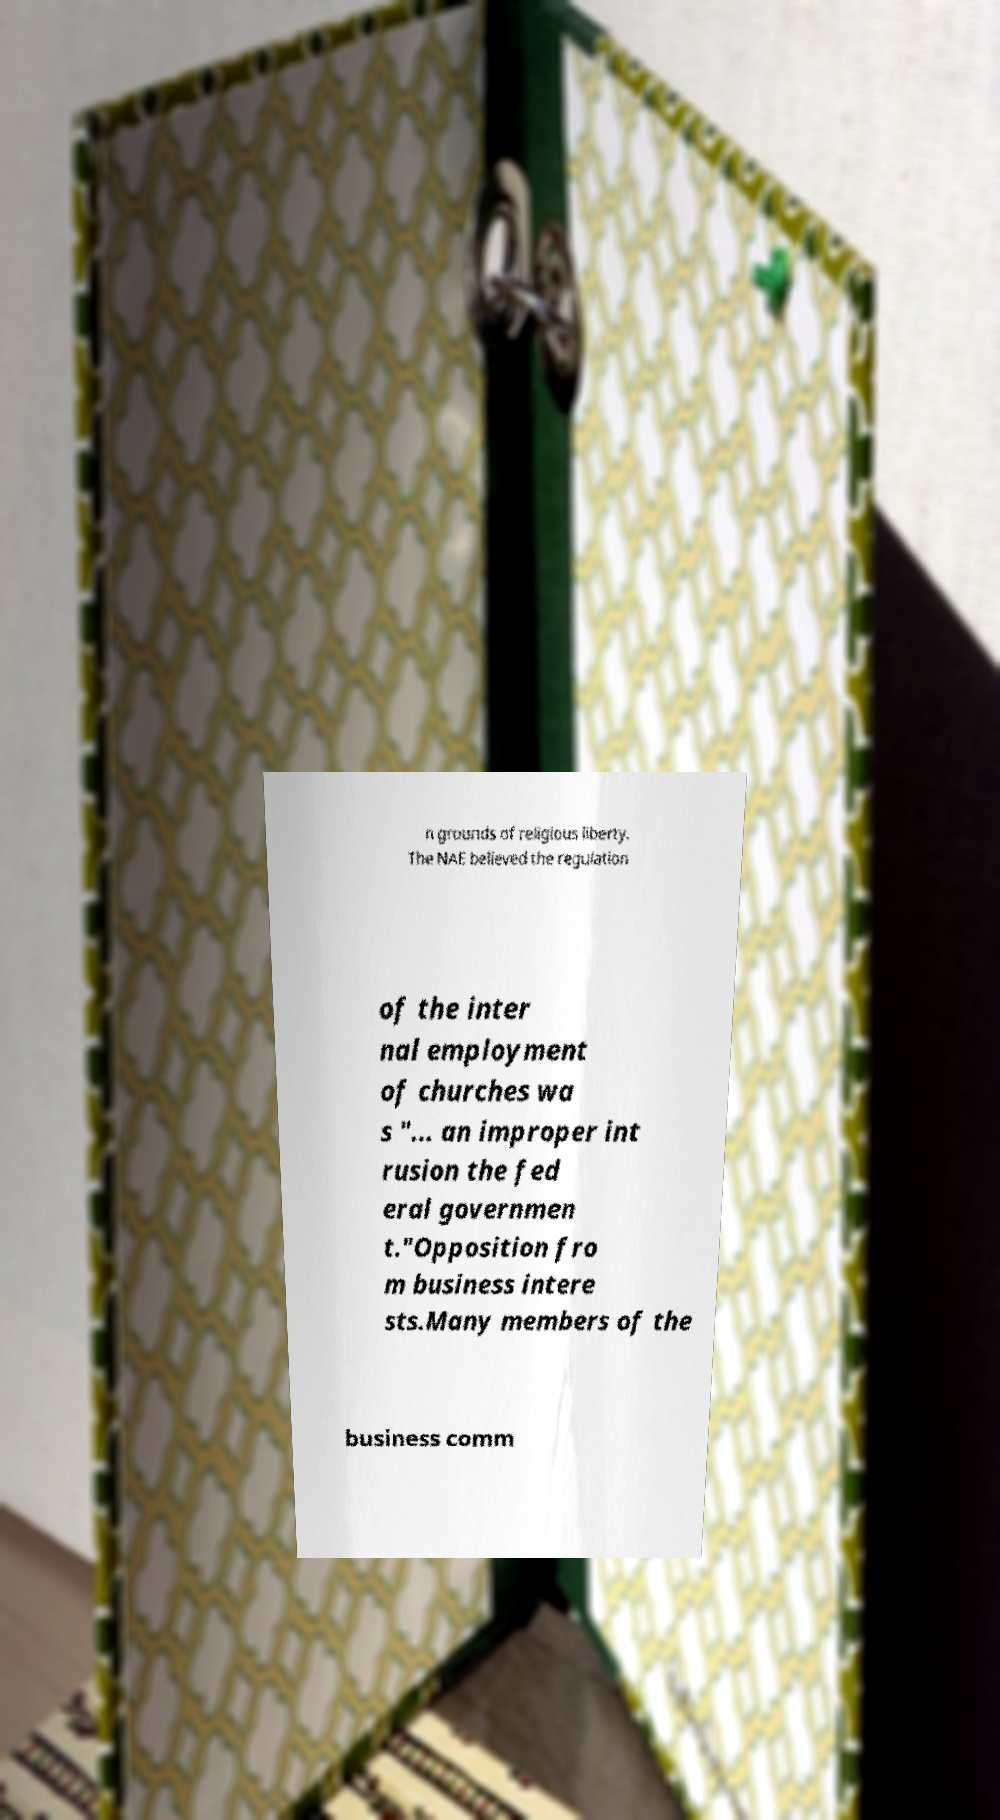Please identify and transcribe the text found in this image. n grounds of religious liberty. The NAE believed the regulation of the inter nal employment of churches wa s "... an improper int rusion the fed eral governmen t."Opposition fro m business intere sts.Many members of the business comm 